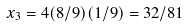Convert formula to latex. <formula><loc_0><loc_0><loc_500><loc_500>x _ { 3 } = 4 ( 8 / 9 ) ( 1 / 9 ) = 3 2 / 8 1</formula> 